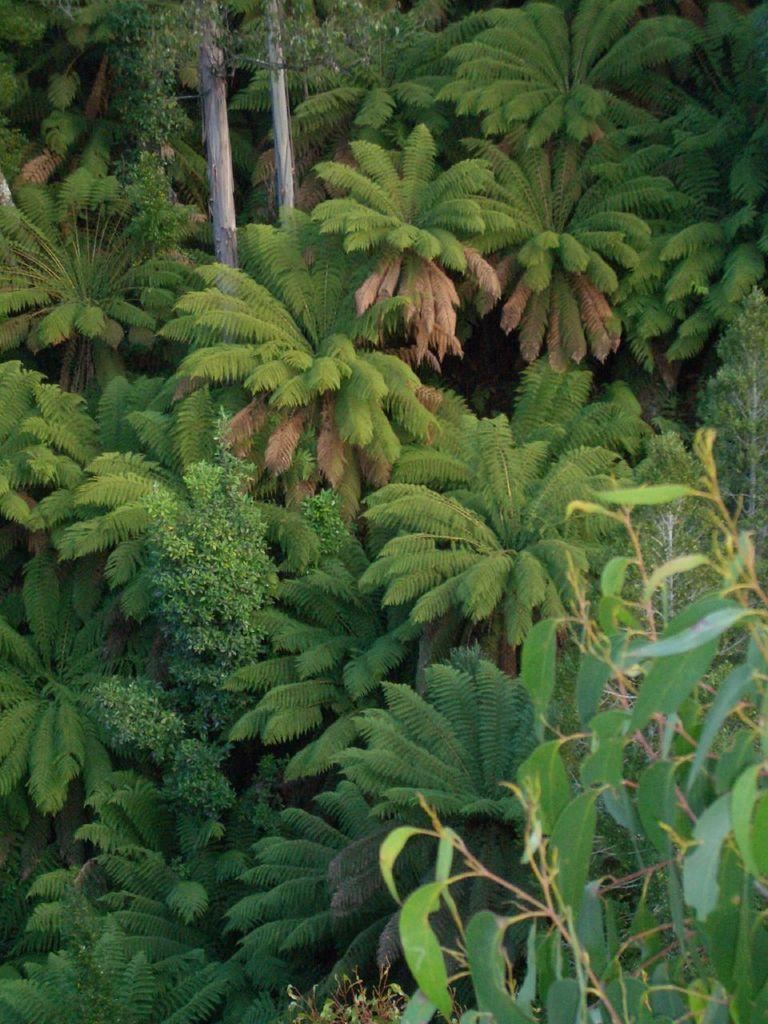What type of vegetation is present in the image? There are many trees in the image. Can you describe any other objects or structures in the image? There are two wooden poles in the image, and they are located between the trees. How many people are wearing a coat while standing near the wooden poles in the image? There are no people present in the image, so it is not possible to determine how many people might be wearing a coat. 